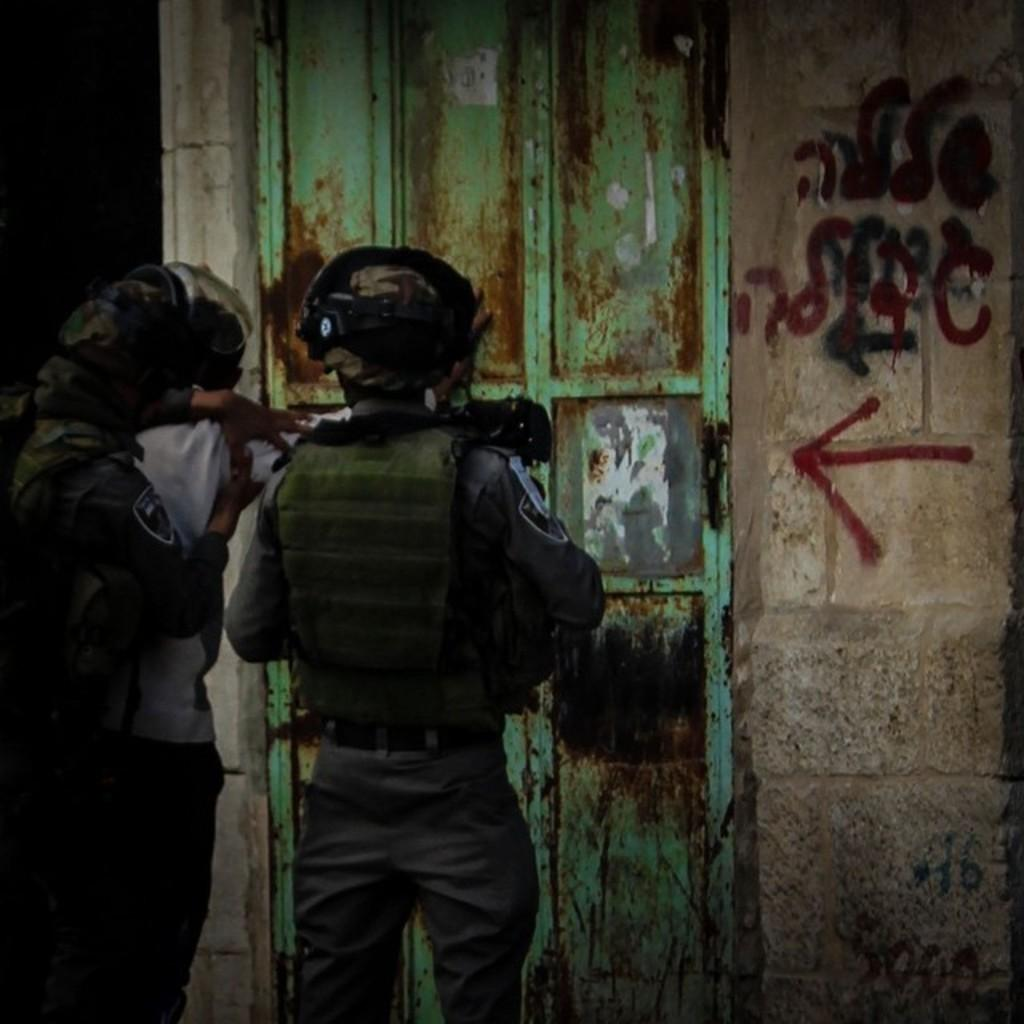What are the people in the image doing? The people in the image are standing near a door. What can be observed about the lighting in the image? The background of the image is dark. What type of patch is being used to gain knowledge in the image? There is no patch or knowledge acquisition activity depicted in the image; it only shows people standing near a door. 